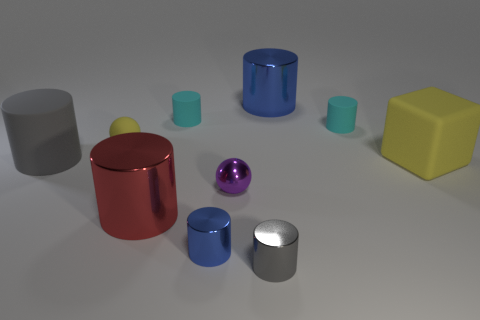What size is the matte cylinder that is both on the left side of the metallic sphere and on the right side of the gray matte object?
Offer a terse response. Small. What is the material of the thing that is the same color as the block?
Your answer should be very brief. Rubber. What number of green metal objects are there?
Offer a very short reply. 0. Is the number of cyan rubber things less than the number of big blue rubber balls?
Ensure brevity in your answer.  No. What material is the blue cylinder that is the same size as the red metal thing?
Provide a succinct answer. Metal. What number of things are yellow things or blue shiny cylinders?
Your response must be concise. 4. How many cylinders are in front of the big yellow cube and behind the large gray object?
Provide a short and direct response. 0. Is the number of tiny gray objects that are behind the tiny yellow matte thing less than the number of matte balls?
Your answer should be compact. Yes. The yellow thing that is the same size as the red thing is what shape?
Provide a succinct answer. Cube. How many other things are there of the same color as the matte sphere?
Provide a succinct answer. 1. 